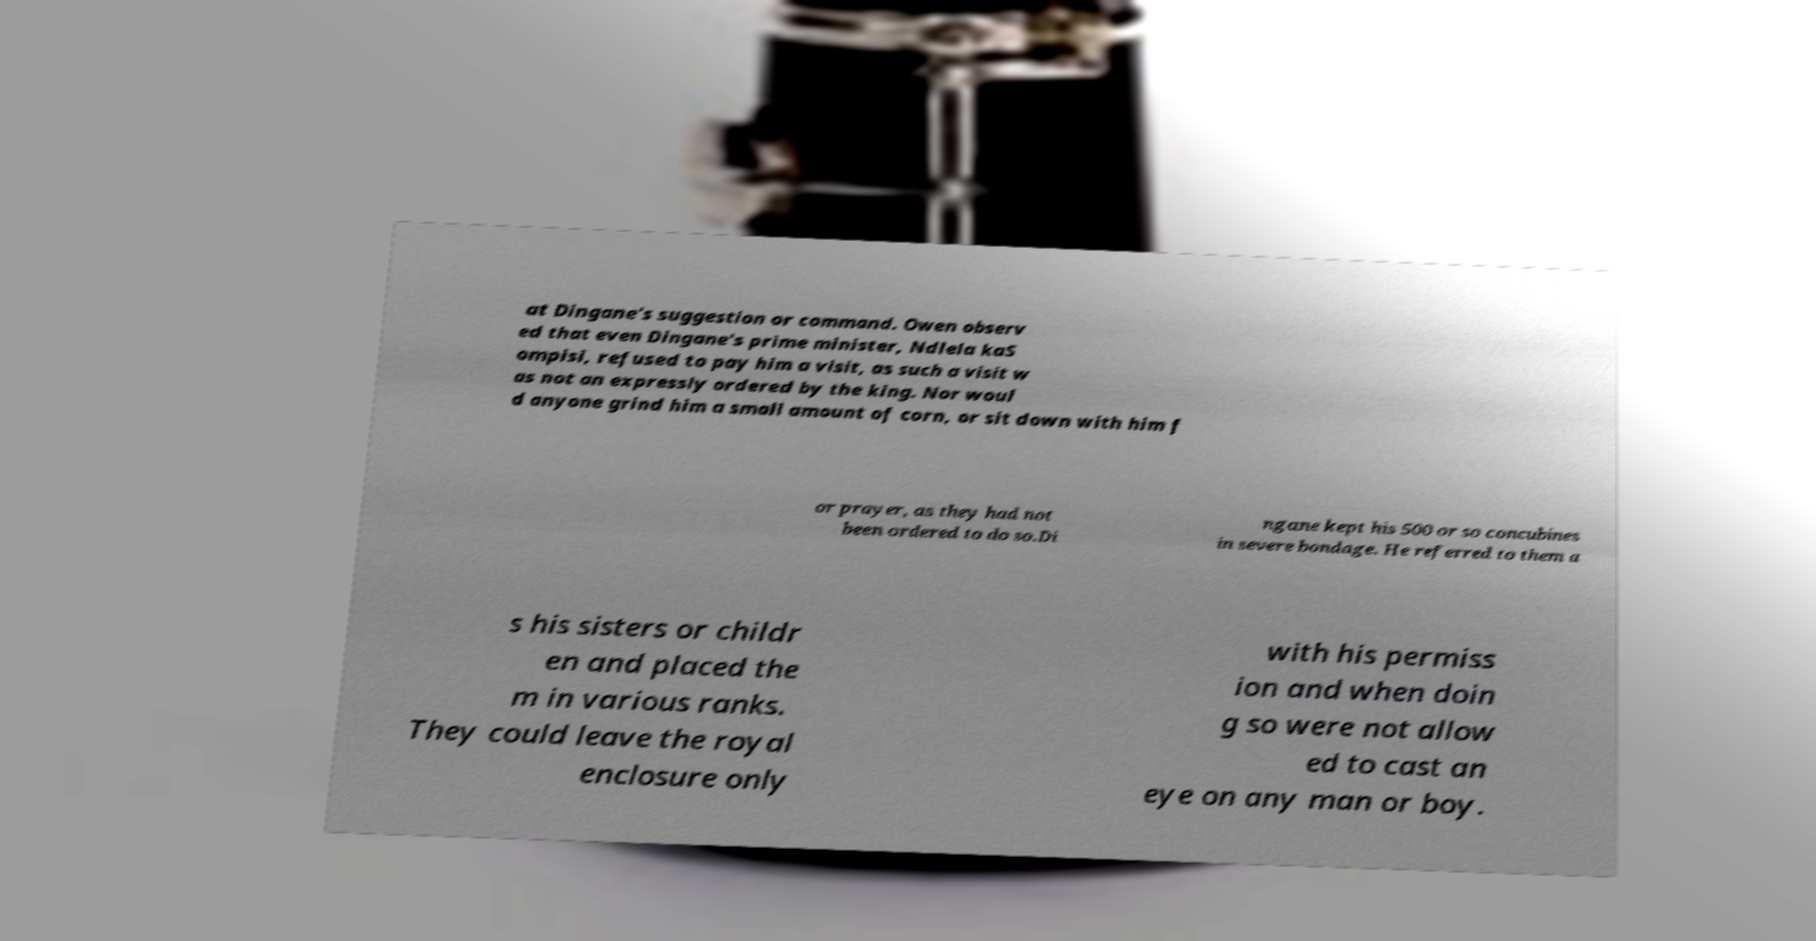What messages or text are displayed in this image? I need them in a readable, typed format. at Dingane's suggestion or command. Owen observ ed that even Dingane's prime minister, Ndlela kaS ompisi, refused to pay him a visit, as such a visit w as not an expressly ordered by the king. Nor woul d anyone grind him a small amount of corn, or sit down with him f or prayer, as they had not been ordered to do so.Di ngane kept his 500 or so concubines in severe bondage. He referred to them a s his sisters or childr en and placed the m in various ranks. They could leave the royal enclosure only with his permiss ion and when doin g so were not allow ed to cast an eye on any man or boy. 